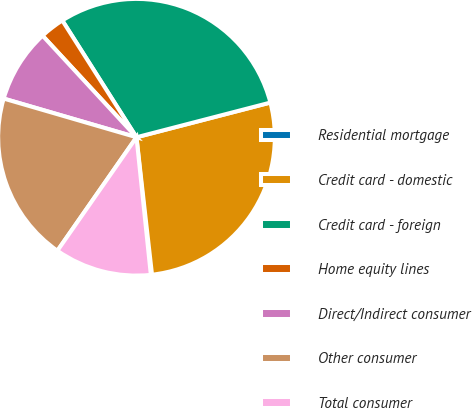<chart> <loc_0><loc_0><loc_500><loc_500><pie_chart><fcel>Residential mortgage<fcel>Credit card - domestic<fcel>Credit card - foreign<fcel>Home equity lines<fcel>Direct/Indirect consumer<fcel>Other consumer<fcel>Total consumer<nl><fcel>0.14%<fcel>27.24%<fcel>29.97%<fcel>2.87%<fcel>8.61%<fcel>19.82%<fcel>11.34%<nl></chart> 